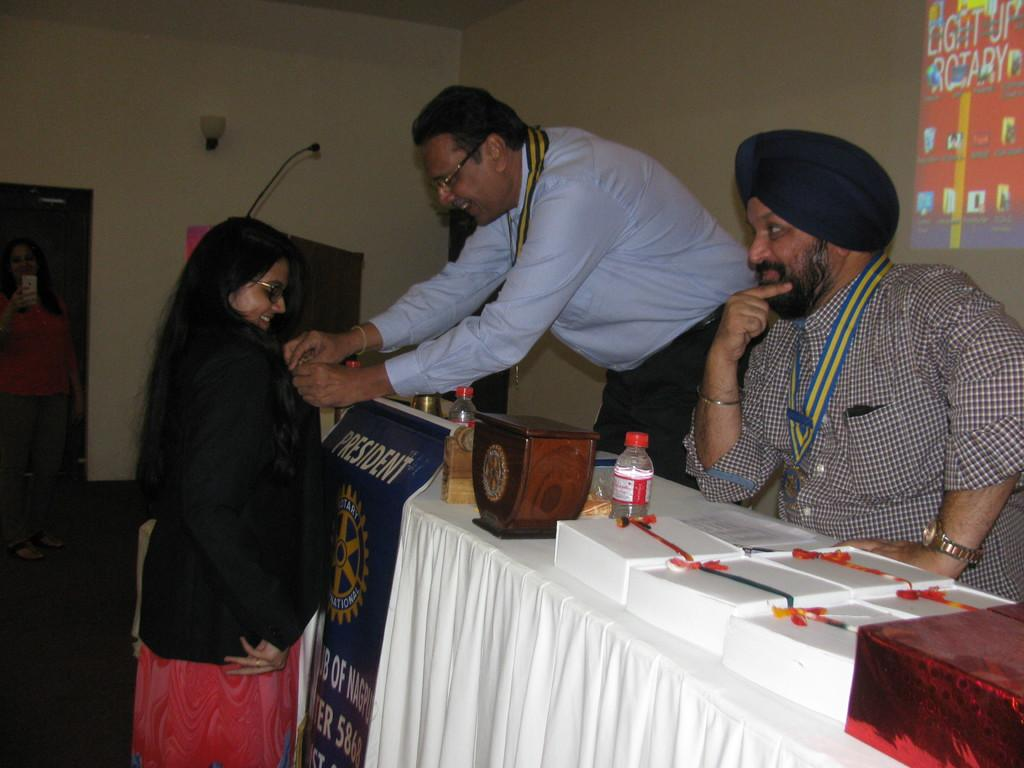<image>
Describe the image concisely. A man behind a President flag leans over to interact with a young woman. 